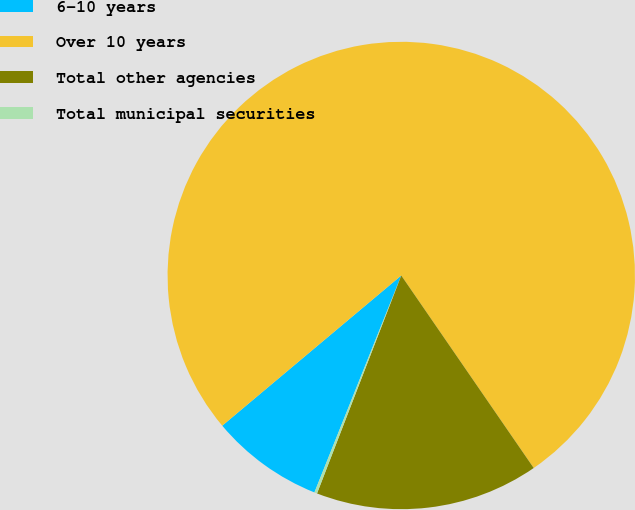Convert chart. <chart><loc_0><loc_0><loc_500><loc_500><pie_chart><fcel>6-10 years<fcel>Over 10 years<fcel>Total other agencies<fcel>Total municipal securities<nl><fcel>7.83%<fcel>76.52%<fcel>15.46%<fcel>0.19%<nl></chart> 